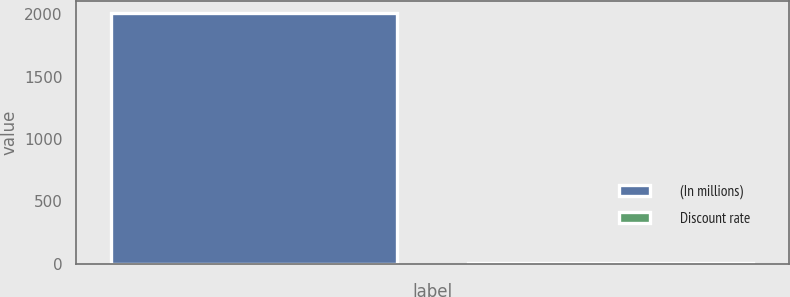Convert chart. <chart><loc_0><loc_0><loc_500><loc_500><bar_chart><fcel>(In millions)<fcel>Discount rate<nl><fcel>2010<fcel>5.94<nl></chart> 